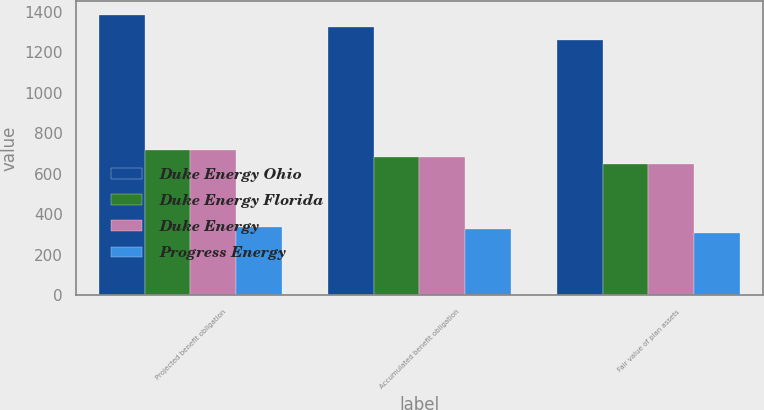Convert chart to OTSL. <chart><loc_0><loc_0><loc_500><loc_500><stacked_bar_chart><ecel><fcel>Projected benefit obligation<fcel>Accumulated benefit obligation<fcel>Fair value of plan assets<nl><fcel>Duke Energy Ohio<fcel>1386<fcel>1326<fcel>1260<nl><fcel>Duke Energy Florida<fcel>718<fcel>683<fcel>650<nl><fcel>Duke Energy<fcel>718<fcel>683<fcel>650<nl><fcel>Progress Energy<fcel>337<fcel>326<fcel>308<nl></chart> 